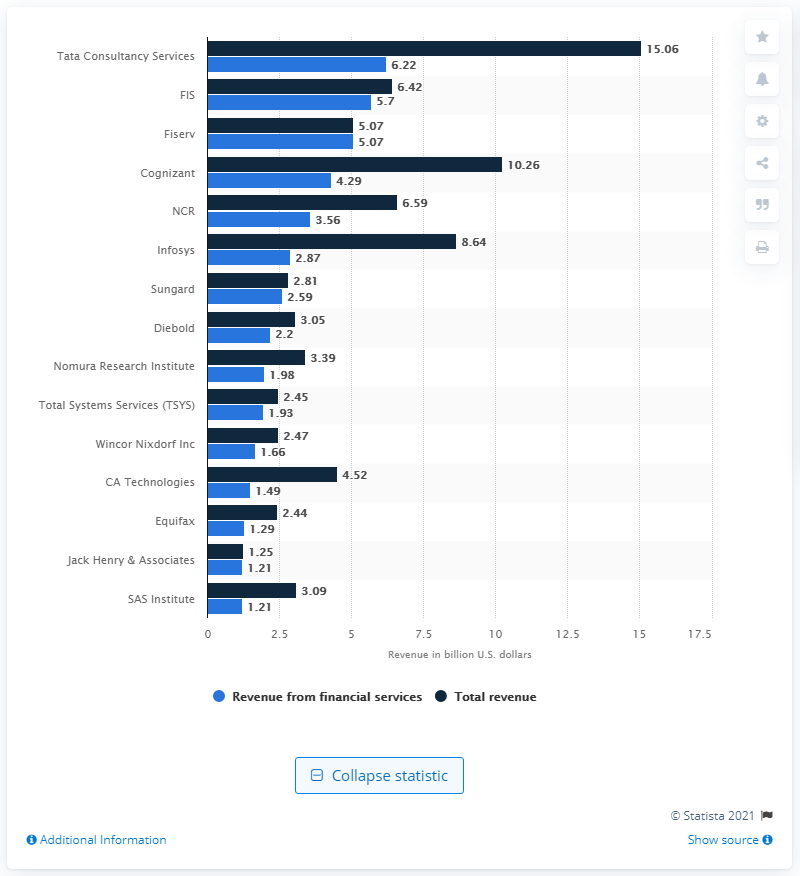Identify some key points in this picture. The revenue generated from financial services by FIS in 2015 was 5.7 billion dollars. 